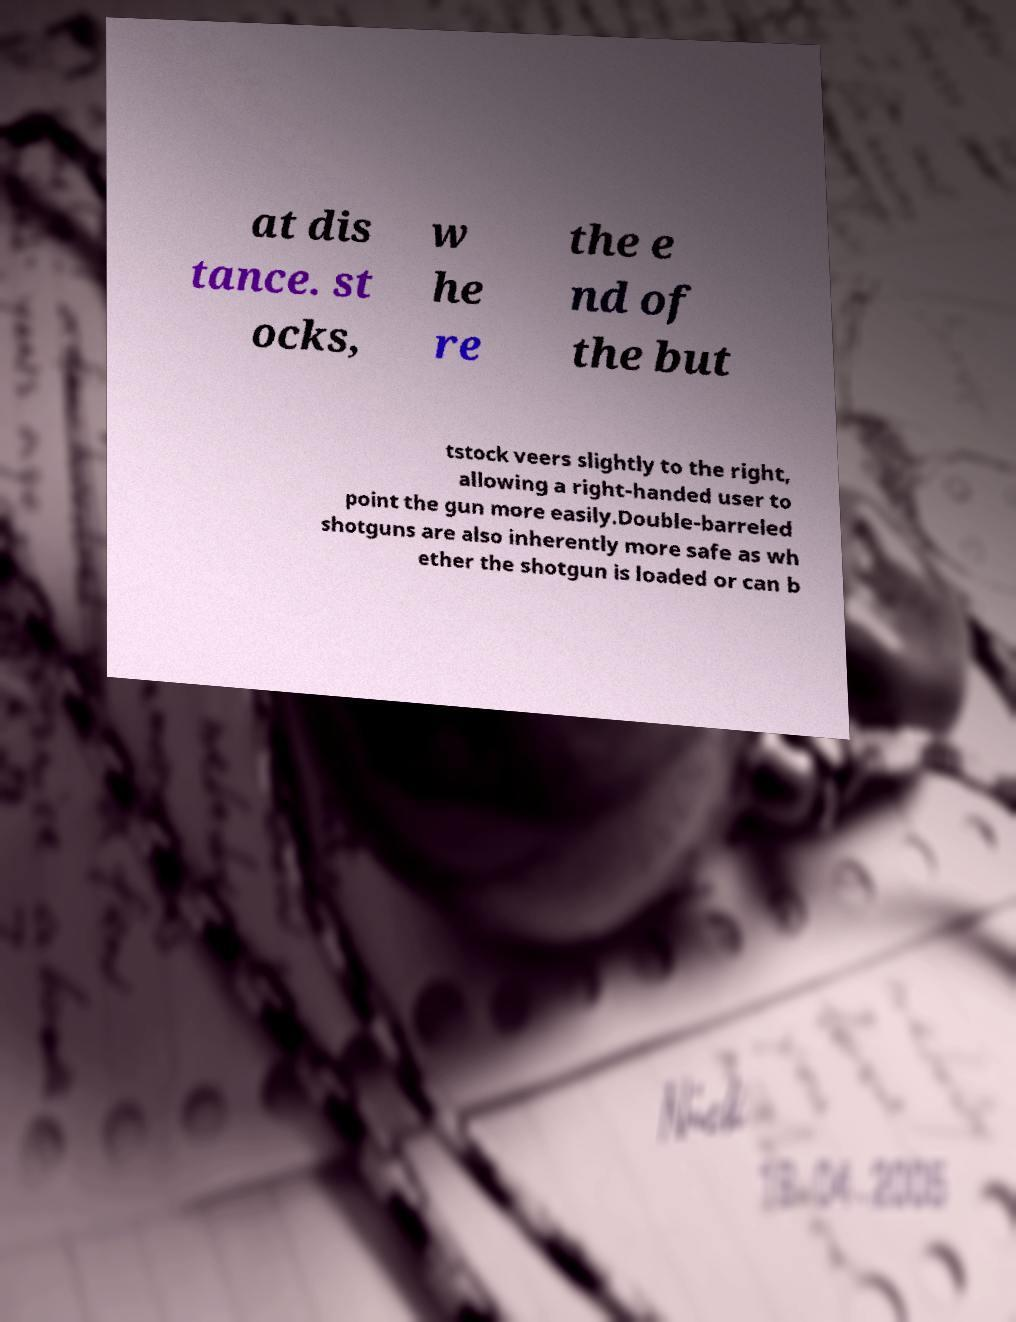For documentation purposes, I need the text within this image transcribed. Could you provide that? at dis tance. st ocks, w he re the e nd of the but tstock veers slightly to the right, allowing a right-handed user to point the gun more easily.Double-barreled shotguns are also inherently more safe as wh ether the shotgun is loaded or can b 